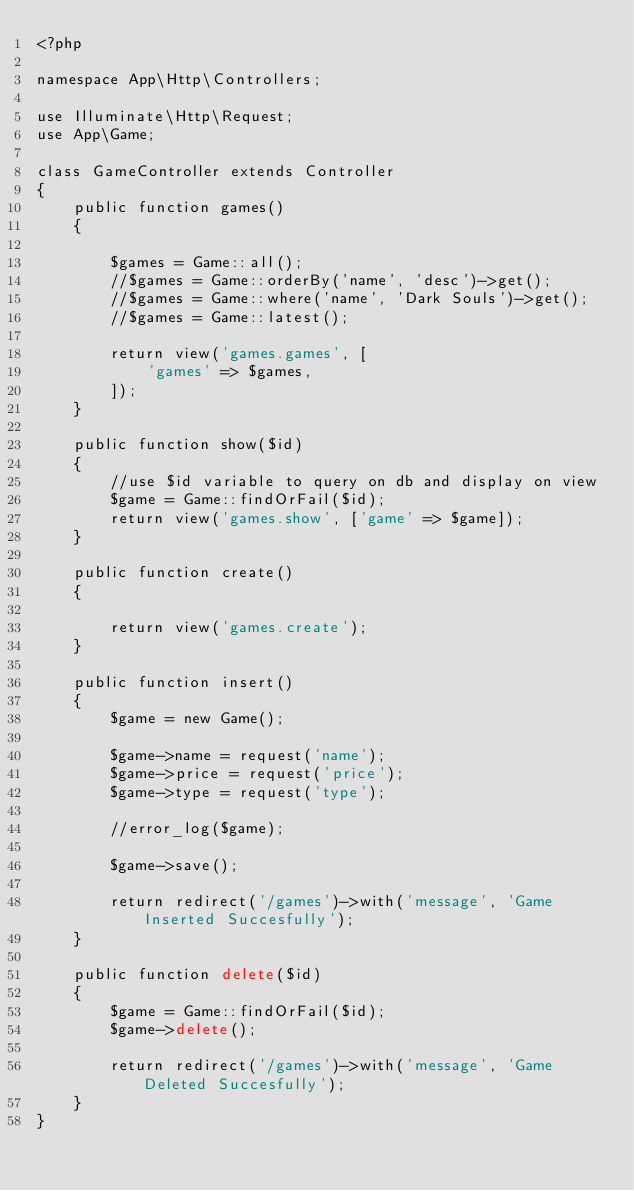Convert code to text. <code><loc_0><loc_0><loc_500><loc_500><_PHP_><?php

namespace App\Http\Controllers;

use Illuminate\Http\Request;
use App\Game;

class GameController extends Controller
{
    public function games()
    {

        $games = Game::all();
        //$games = Game::orderBy('name', 'desc')->get();
        //$games = Game::where('name', 'Dark Souls')->get();
        //$games = Game::latest();

        return view('games.games', [
            'games' => $games,
        ]);
    }

    public function show($id)
    {
        //use $id variable to query on db and display on view
        $game = Game::findOrFail($id);
        return view('games.show', ['game' => $game]);
    }

    public function create()
    {

        return view('games.create');
    }

    public function insert()
    {
        $game = new Game();

        $game->name = request('name');
        $game->price = request('price');
        $game->type = request('type');

        //error_log($game);

        $game->save();

        return redirect('/games')->with('message', 'Game Inserted Succesfully');
    }

    public function delete($id)
    {
        $game = Game::findOrFail($id);
        $game->delete();

        return redirect('/games')->with('message', 'Game Deleted Succesfully');
    }
}
</code> 